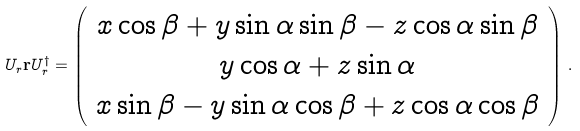<formula> <loc_0><loc_0><loc_500><loc_500>U _ { r } \mathbf r U _ { r } ^ { \dagger } = \left ( \begin{array} { c } x \cos \beta + y \sin \alpha \sin \beta - z \cos \alpha \sin \beta \\ y \cos \alpha + z \sin \alpha \\ x \sin \beta - y \sin \alpha \cos \beta + z \cos \alpha \cos \beta \end{array} \right ) \, .</formula> 